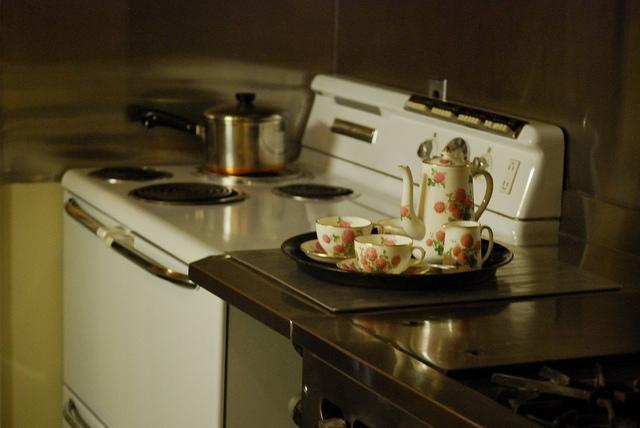How many cups are in the picture?
Give a very brief answer. 2. 